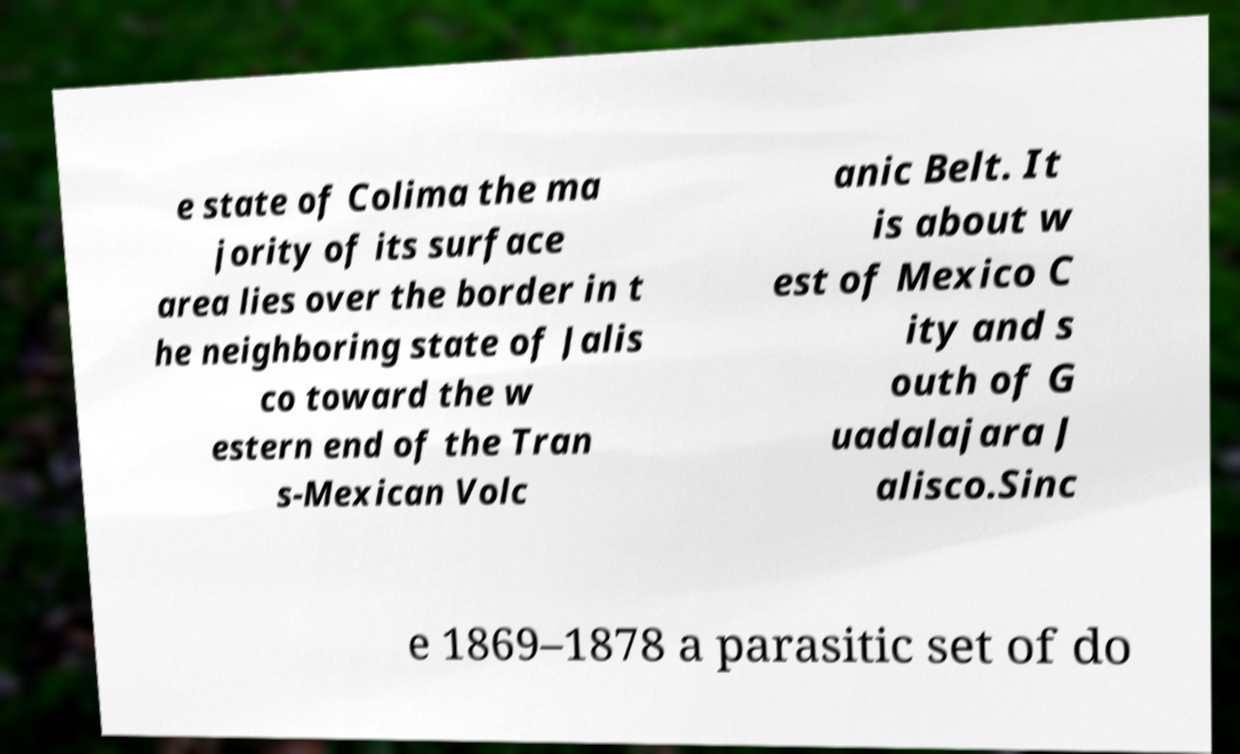For documentation purposes, I need the text within this image transcribed. Could you provide that? e state of Colima the ma jority of its surface area lies over the border in t he neighboring state of Jalis co toward the w estern end of the Tran s-Mexican Volc anic Belt. It is about w est of Mexico C ity and s outh of G uadalajara J alisco.Sinc e 1869–1878 a parasitic set of do 